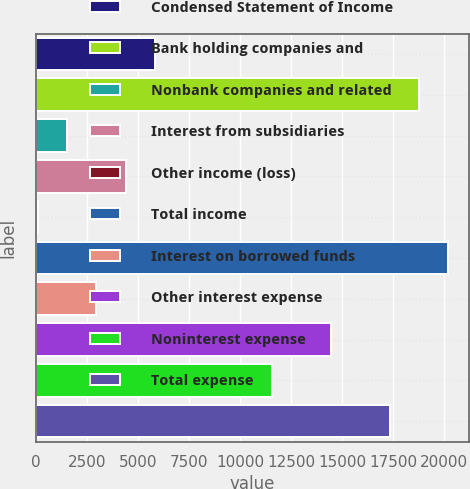Convert chart to OTSL. <chart><loc_0><loc_0><loc_500><loc_500><bar_chart><fcel>Condensed Statement of Income<fcel>Bank holding companies and<fcel>Nonbank companies and related<fcel>Interest from subsidiaries<fcel>Other income (loss)<fcel>Total income<fcel>Interest on borrowed funds<fcel>Other interest expense<fcel>Noninterest expense<fcel>Total expense<nl><fcel>5826<fcel>18772.5<fcel>1510.5<fcel>4387.5<fcel>72<fcel>20211<fcel>2949<fcel>14457<fcel>11580<fcel>17334<nl></chart> 